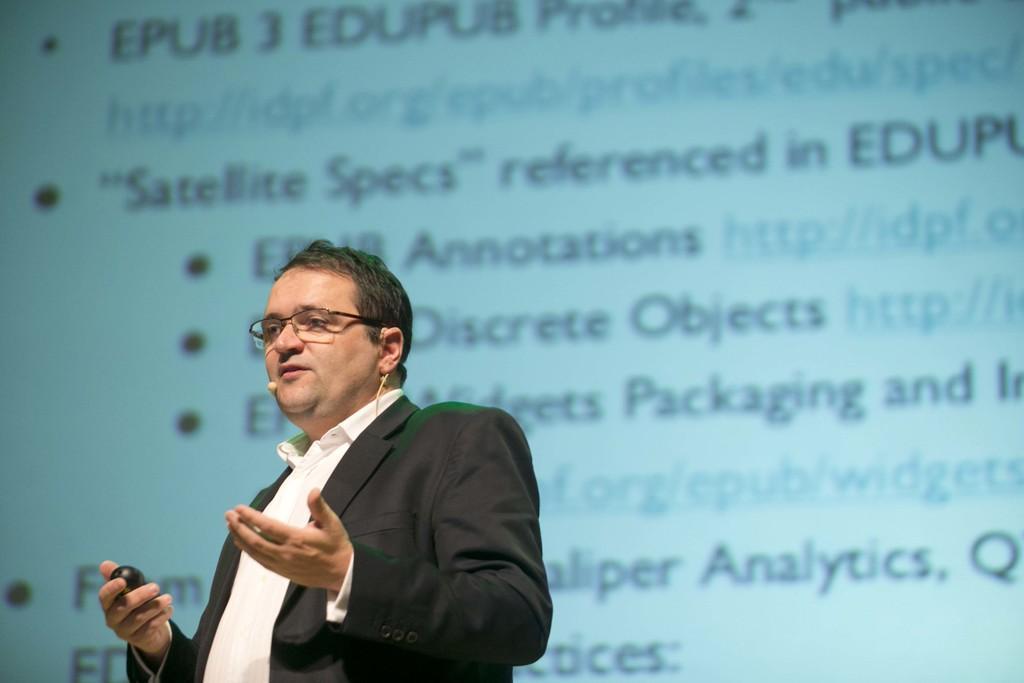How would you summarize this image in a sentence or two? This is the man standing. He wore a shirt, suit and spectacles. He is holding an object in his hand. In the background, that looks like a screen with the display. 